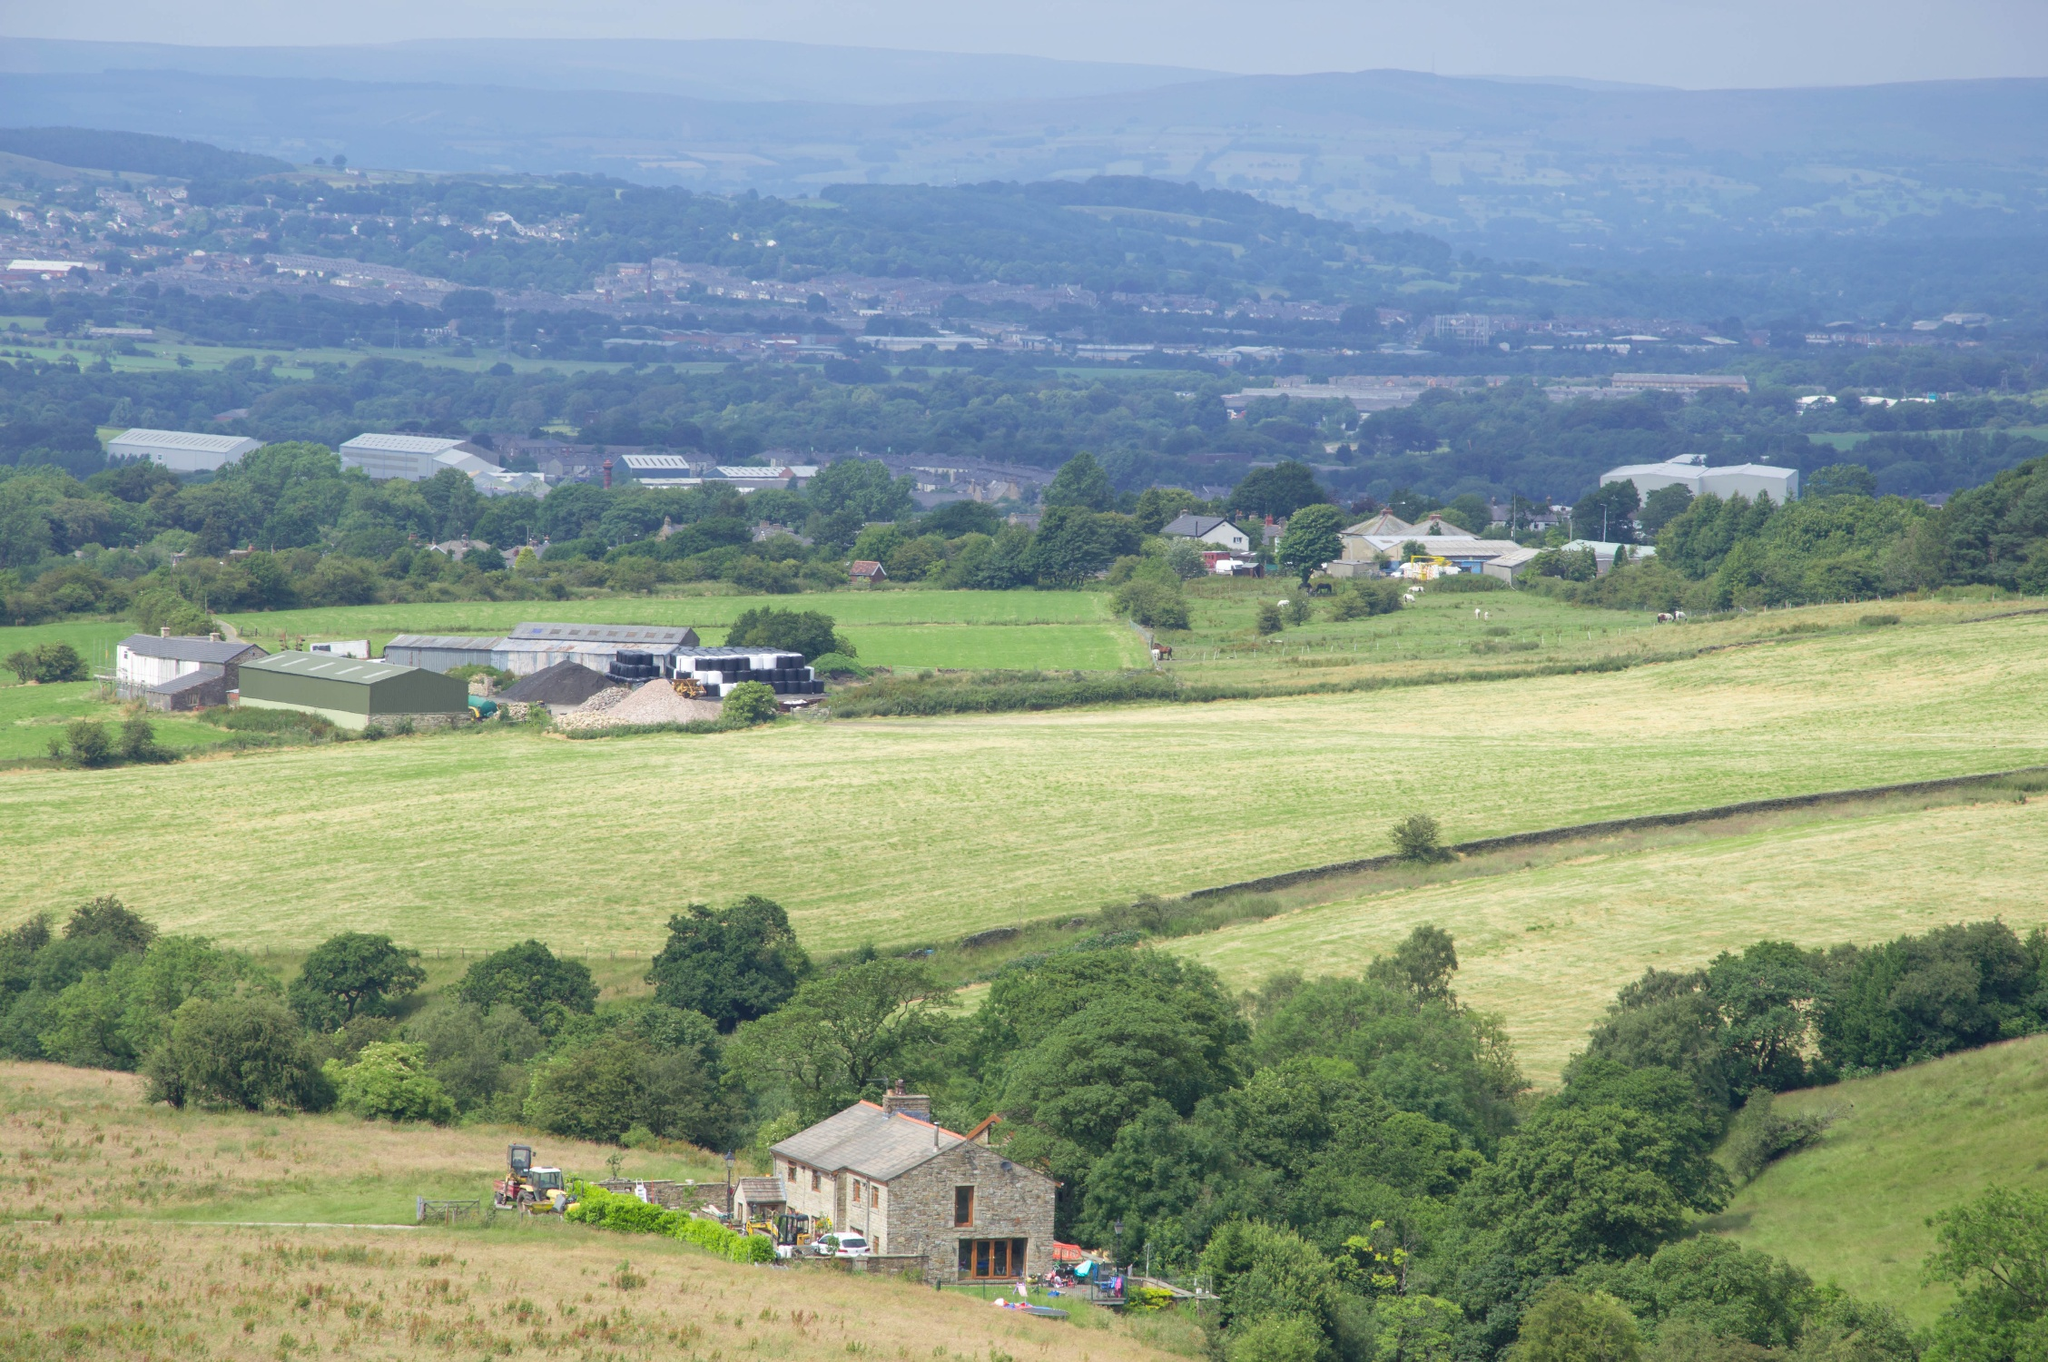How might the weather conditions affect this landscape throughout the year? This landscape, characterized by its open fields, gentle hills, and tree-lined borders, will experience notable changes with the seasons. In spring and summer, the abundance of sunlight and moderate rainfall can create optimal conditions for crop growth and lush greenery. Conversely, during autumn, the region may witness a picturesque transformation as leaves change color and crops are harvested. Winter could bring frost, snow, and colder temperatures, potentially affecting year-round agriculture. The varied topography, including the hills and tree lines, helps create microclimates that mitigate wind impact, offering pockets of shelter that can benefit certain crops and livestock. The overall agricultural productivity will hinge on how well these factors are managed throughout the seasonal shifts. 